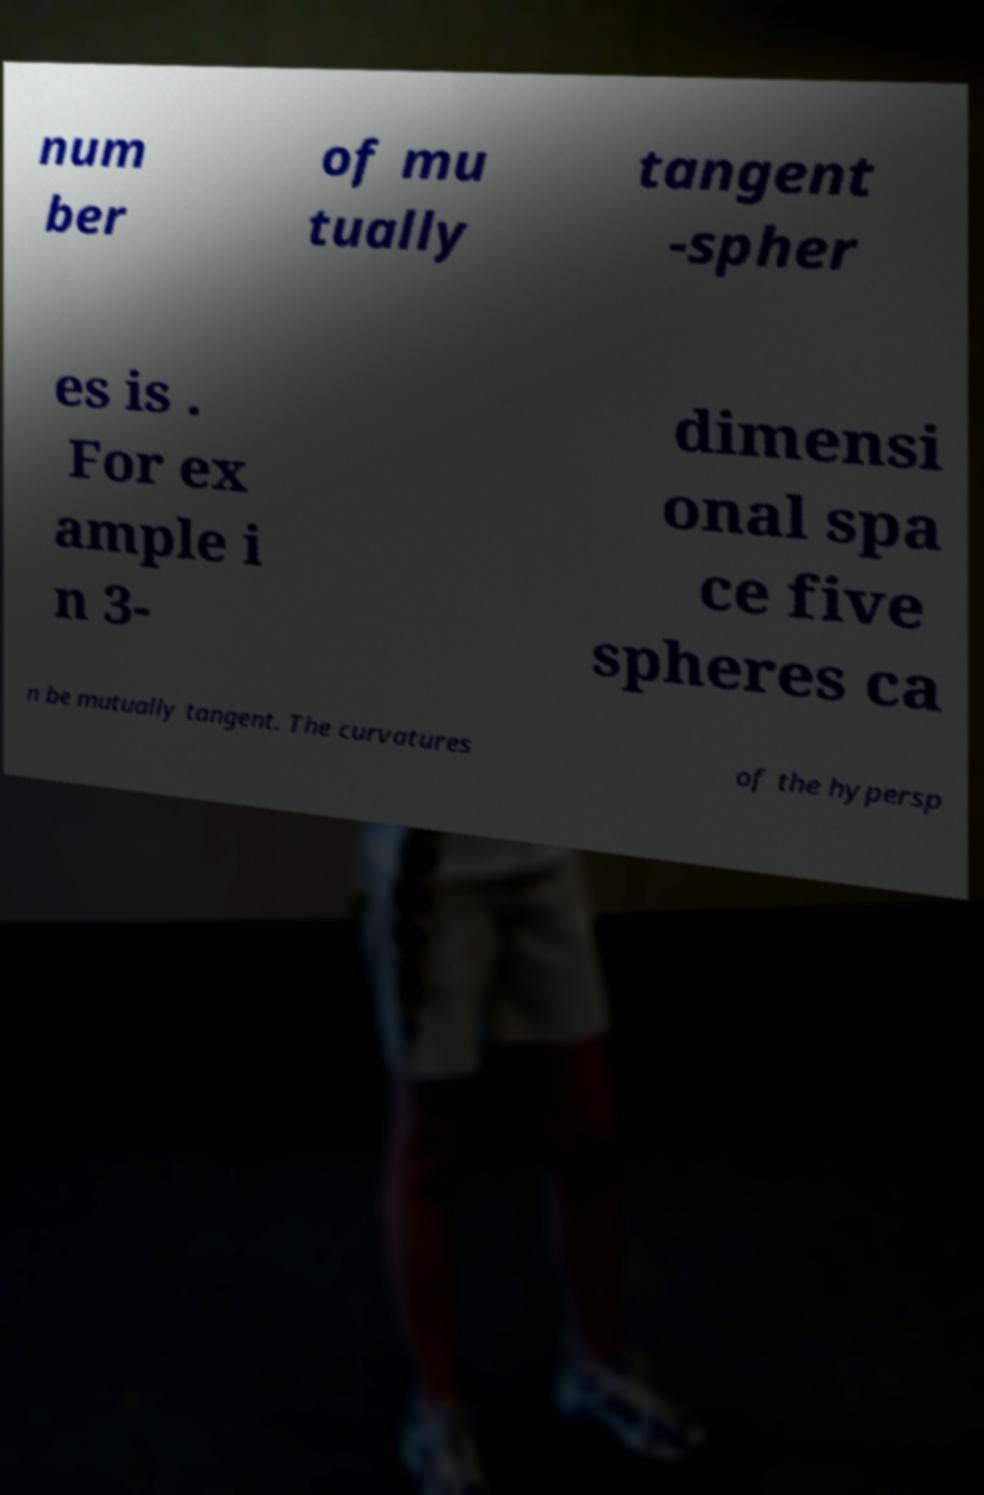Please identify and transcribe the text found in this image. num ber of mu tually tangent -spher es is . For ex ample i n 3- dimensi onal spa ce five spheres ca n be mutually tangent. The curvatures of the hypersp 